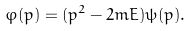<formula> <loc_0><loc_0><loc_500><loc_500>\varphi ( p ) = ( p ^ { 2 } - 2 m E ) \psi ( p ) .</formula> 